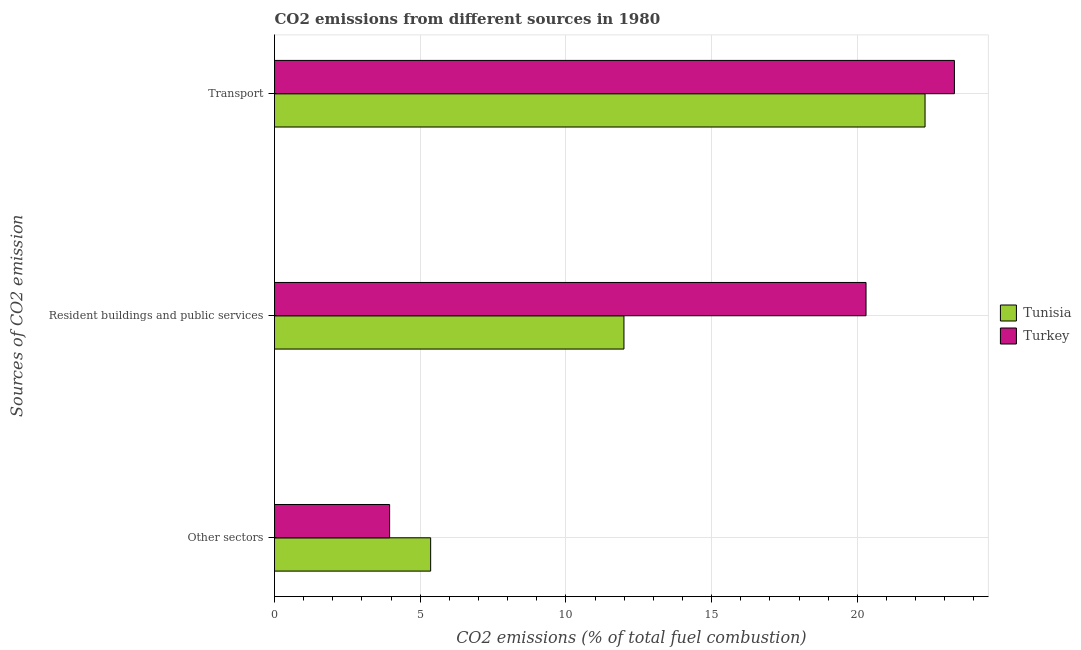How many groups of bars are there?
Keep it short and to the point. 3. Are the number of bars on each tick of the Y-axis equal?
Your answer should be compact. Yes. How many bars are there on the 3rd tick from the top?
Provide a succinct answer. 2. How many bars are there on the 3rd tick from the bottom?
Your answer should be compact. 2. What is the label of the 2nd group of bars from the top?
Keep it short and to the point. Resident buildings and public services. What is the percentage of co2 emissions from transport in Tunisia?
Keep it short and to the point. 22.32. Across all countries, what is the maximum percentage of co2 emissions from transport?
Keep it short and to the point. 23.33. Across all countries, what is the minimum percentage of co2 emissions from resident buildings and public services?
Keep it short and to the point. 11.99. In which country was the percentage of co2 emissions from resident buildings and public services minimum?
Your response must be concise. Tunisia. What is the total percentage of co2 emissions from transport in the graph?
Provide a succinct answer. 45.65. What is the difference between the percentage of co2 emissions from resident buildings and public services in Turkey and that in Tunisia?
Your answer should be compact. 8.31. What is the difference between the percentage of co2 emissions from resident buildings and public services in Turkey and the percentage of co2 emissions from other sectors in Tunisia?
Provide a short and direct response. 14.94. What is the average percentage of co2 emissions from transport per country?
Provide a succinct answer. 22.83. What is the difference between the percentage of co2 emissions from transport and percentage of co2 emissions from other sectors in Tunisia?
Ensure brevity in your answer.  16.96. In how many countries, is the percentage of co2 emissions from transport greater than 22 %?
Provide a short and direct response. 2. What is the ratio of the percentage of co2 emissions from transport in Tunisia to that in Turkey?
Offer a terse response. 0.96. Is the difference between the percentage of co2 emissions from other sectors in Tunisia and Turkey greater than the difference between the percentage of co2 emissions from transport in Tunisia and Turkey?
Ensure brevity in your answer.  Yes. What is the difference between the highest and the second highest percentage of co2 emissions from resident buildings and public services?
Offer a very short reply. 8.31. What is the difference between the highest and the lowest percentage of co2 emissions from transport?
Give a very brief answer. 1.01. In how many countries, is the percentage of co2 emissions from transport greater than the average percentage of co2 emissions from transport taken over all countries?
Your response must be concise. 1. What does the 1st bar from the bottom in Other sectors represents?
Make the answer very short. Tunisia. Are all the bars in the graph horizontal?
Offer a terse response. Yes. Does the graph contain grids?
Keep it short and to the point. Yes. What is the title of the graph?
Offer a very short reply. CO2 emissions from different sources in 1980. What is the label or title of the X-axis?
Provide a short and direct response. CO2 emissions (% of total fuel combustion). What is the label or title of the Y-axis?
Your answer should be very brief. Sources of CO2 emission. What is the CO2 emissions (% of total fuel combustion) of Tunisia in Other sectors?
Make the answer very short. 5.36. What is the CO2 emissions (% of total fuel combustion) of Turkey in Other sectors?
Provide a succinct answer. 3.95. What is the CO2 emissions (% of total fuel combustion) in Tunisia in Resident buildings and public services?
Keep it short and to the point. 11.99. What is the CO2 emissions (% of total fuel combustion) of Turkey in Resident buildings and public services?
Provide a short and direct response. 20.3. What is the CO2 emissions (% of total fuel combustion) of Tunisia in Transport?
Offer a very short reply. 22.32. What is the CO2 emissions (% of total fuel combustion) of Turkey in Transport?
Make the answer very short. 23.33. Across all Sources of CO2 emission, what is the maximum CO2 emissions (% of total fuel combustion) in Tunisia?
Your response must be concise. 22.32. Across all Sources of CO2 emission, what is the maximum CO2 emissions (% of total fuel combustion) of Turkey?
Offer a terse response. 23.33. Across all Sources of CO2 emission, what is the minimum CO2 emissions (% of total fuel combustion) in Tunisia?
Your answer should be compact. 5.36. Across all Sources of CO2 emission, what is the minimum CO2 emissions (% of total fuel combustion) of Turkey?
Offer a terse response. 3.95. What is the total CO2 emissions (% of total fuel combustion) of Tunisia in the graph?
Your response must be concise. 39.67. What is the total CO2 emissions (% of total fuel combustion) in Turkey in the graph?
Your answer should be compact. 47.57. What is the difference between the CO2 emissions (% of total fuel combustion) of Tunisia in Other sectors and that in Resident buildings and public services?
Offer a terse response. -6.63. What is the difference between the CO2 emissions (% of total fuel combustion) of Turkey in Other sectors and that in Resident buildings and public services?
Ensure brevity in your answer.  -16.35. What is the difference between the CO2 emissions (% of total fuel combustion) of Tunisia in Other sectors and that in Transport?
Your answer should be very brief. -16.96. What is the difference between the CO2 emissions (% of total fuel combustion) of Turkey in Other sectors and that in Transport?
Give a very brief answer. -19.38. What is the difference between the CO2 emissions (% of total fuel combustion) of Tunisia in Resident buildings and public services and that in Transport?
Offer a very short reply. -10.33. What is the difference between the CO2 emissions (% of total fuel combustion) of Turkey in Resident buildings and public services and that in Transport?
Make the answer very short. -3.03. What is the difference between the CO2 emissions (% of total fuel combustion) of Tunisia in Other sectors and the CO2 emissions (% of total fuel combustion) of Turkey in Resident buildings and public services?
Ensure brevity in your answer.  -14.94. What is the difference between the CO2 emissions (% of total fuel combustion) in Tunisia in Other sectors and the CO2 emissions (% of total fuel combustion) in Turkey in Transport?
Keep it short and to the point. -17.97. What is the difference between the CO2 emissions (% of total fuel combustion) in Tunisia in Resident buildings and public services and the CO2 emissions (% of total fuel combustion) in Turkey in Transport?
Provide a short and direct response. -11.34. What is the average CO2 emissions (% of total fuel combustion) of Tunisia per Sources of CO2 emission?
Provide a succinct answer. 13.22. What is the average CO2 emissions (% of total fuel combustion) of Turkey per Sources of CO2 emission?
Keep it short and to the point. 15.86. What is the difference between the CO2 emissions (% of total fuel combustion) of Tunisia and CO2 emissions (% of total fuel combustion) of Turkey in Other sectors?
Give a very brief answer. 1.41. What is the difference between the CO2 emissions (% of total fuel combustion) of Tunisia and CO2 emissions (% of total fuel combustion) of Turkey in Resident buildings and public services?
Keep it short and to the point. -8.31. What is the difference between the CO2 emissions (% of total fuel combustion) in Tunisia and CO2 emissions (% of total fuel combustion) in Turkey in Transport?
Provide a short and direct response. -1.01. What is the ratio of the CO2 emissions (% of total fuel combustion) of Tunisia in Other sectors to that in Resident buildings and public services?
Your response must be concise. 0.45. What is the ratio of the CO2 emissions (% of total fuel combustion) in Turkey in Other sectors to that in Resident buildings and public services?
Your response must be concise. 0.19. What is the ratio of the CO2 emissions (% of total fuel combustion) of Tunisia in Other sectors to that in Transport?
Keep it short and to the point. 0.24. What is the ratio of the CO2 emissions (% of total fuel combustion) in Turkey in Other sectors to that in Transport?
Your answer should be very brief. 0.17. What is the ratio of the CO2 emissions (% of total fuel combustion) of Tunisia in Resident buildings and public services to that in Transport?
Ensure brevity in your answer.  0.54. What is the ratio of the CO2 emissions (% of total fuel combustion) of Turkey in Resident buildings and public services to that in Transport?
Keep it short and to the point. 0.87. What is the difference between the highest and the second highest CO2 emissions (% of total fuel combustion) in Tunisia?
Offer a terse response. 10.33. What is the difference between the highest and the second highest CO2 emissions (% of total fuel combustion) of Turkey?
Provide a succinct answer. 3.03. What is the difference between the highest and the lowest CO2 emissions (% of total fuel combustion) of Tunisia?
Your answer should be very brief. 16.96. What is the difference between the highest and the lowest CO2 emissions (% of total fuel combustion) in Turkey?
Provide a succinct answer. 19.38. 